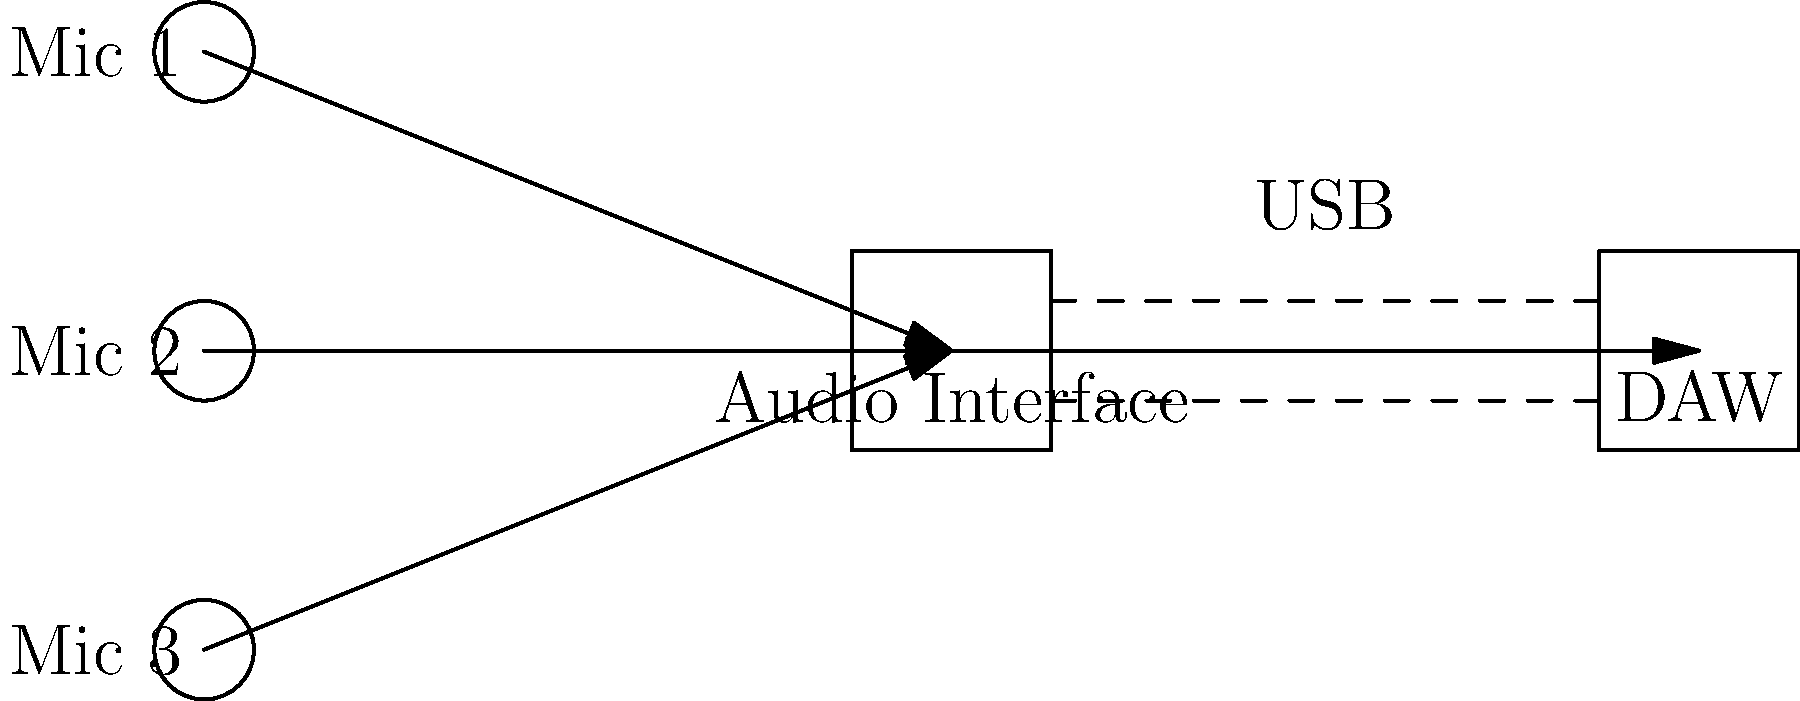In the diagram of a typical podcast production setup, what is the primary purpose of the audio interface in the signal flow? To understand the role of the audio interface in a podcast production setup, let's break down the signal flow:

1. Microphones: The diagram shows three microphones (Mic 1, Mic 2, Mic 3) which capture the audio signals from the speakers or hosts.

2. Audio Interface: All three microphones are connected to the audio interface. The audio interface serves several crucial functions:
   a) It converts the analog signals from the microphones into digital signals that can be processed by a computer.
   b) It provides preamps to boost the microphone signals to an appropriate level.
   c) It often includes analog-to-digital (A/D) converters to digitize the audio.
   d) It may also provide phantom power for condenser microphones.

3. USB Connection: The audio interface is connected to the Digital Audio Workstation (DAW) via a USB connection, as indicated by the dashed lines in the diagram.

4. DAW (Digital Audio Workstation): This is the software where the digital audio signals are recorded, edited, and mixed.

The primary purpose of the audio interface in this setup is to act as a bridge between the analog world (microphones) and the digital world (computer/DAW). It converts the analog signals from the microphones into digital data that can be processed and recorded by the DAW software.
Answer: Analog-to-digital conversion 